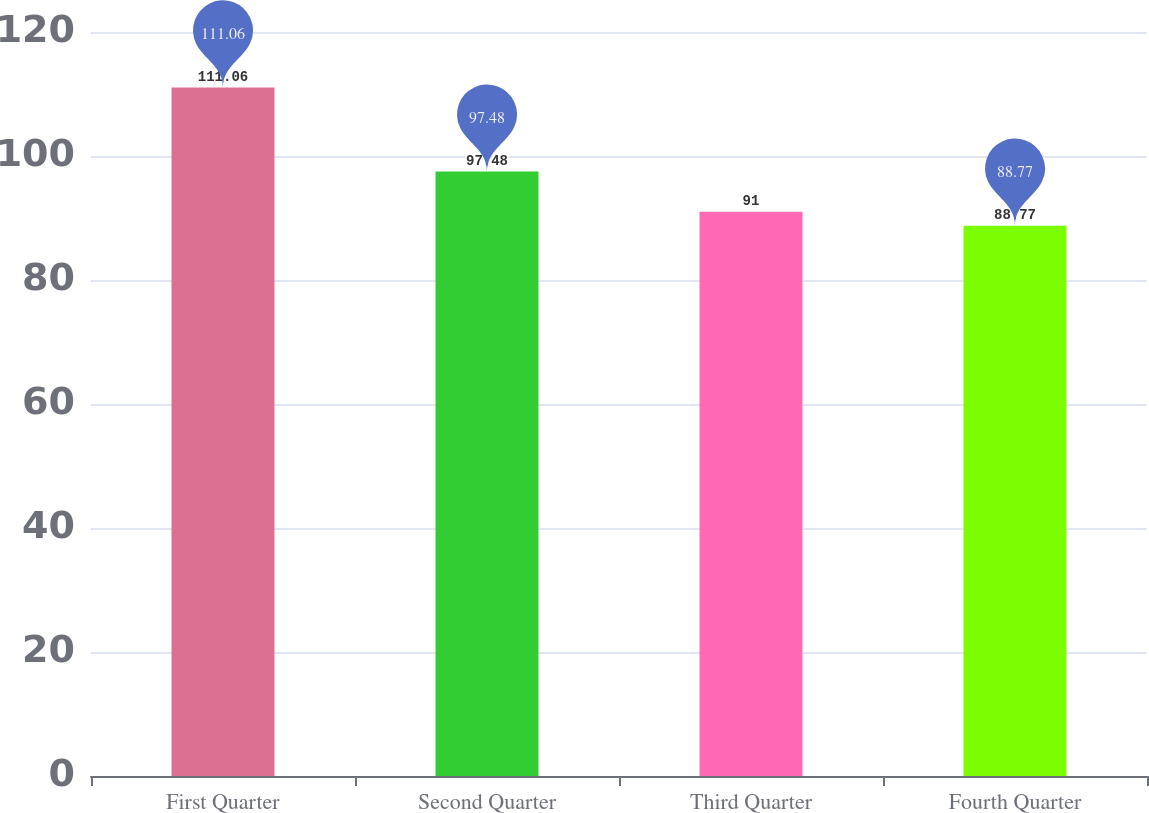Convert chart to OTSL. <chart><loc_0><loc_0><loc_500><loc_500><bar_chart><fcel>First Quarter<fcel>Second Quarter<fcel>Third Quarter<fcel>Fourth Quarter<nl><fcel>111.06<fcel>97.48<fcel>91<fcel>88.77<nl></chart> 